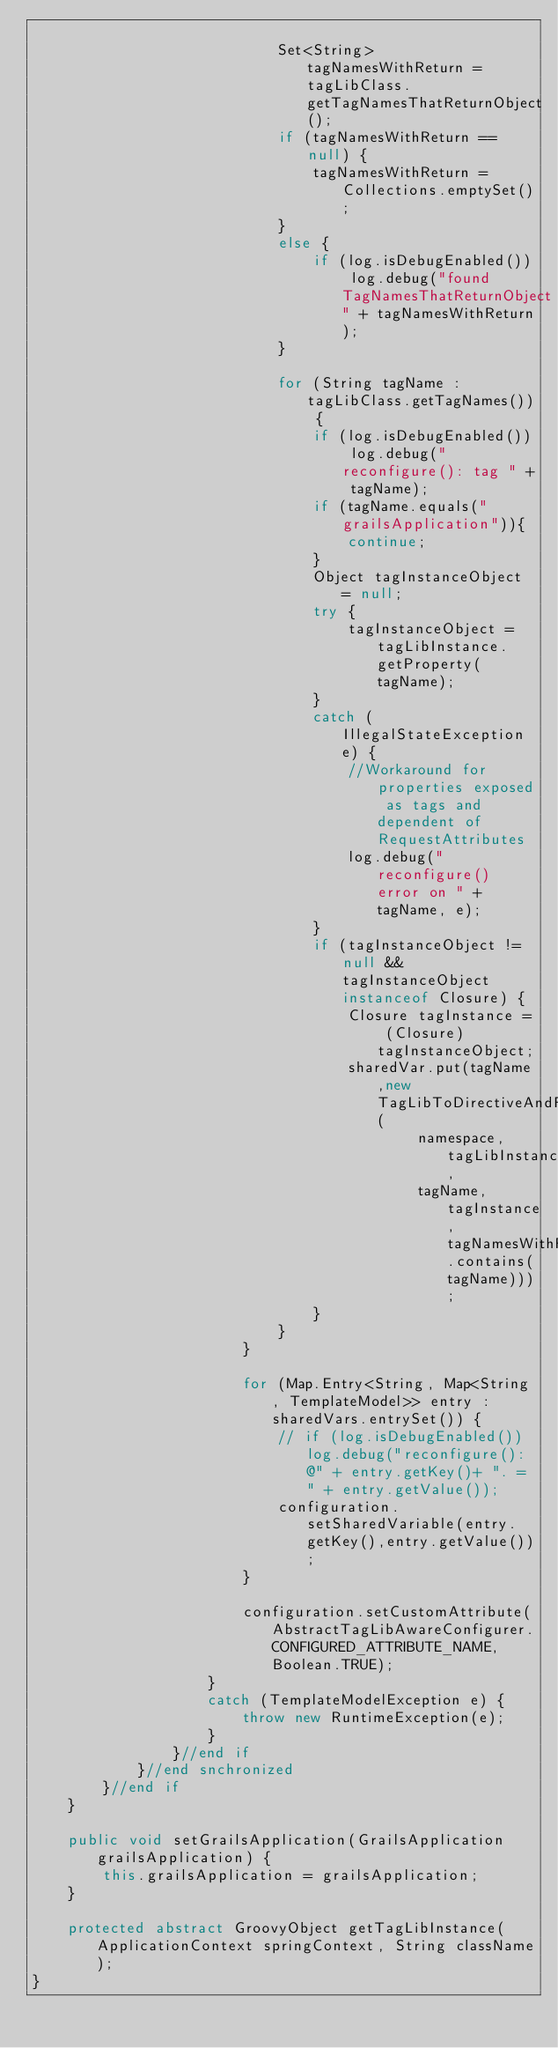<code> <loc_0><loc_0><loc_500><loc_500><_Java_>
                            Set<String> tagNamesWithReturn = tagLibClass.getTagNamesThatReturnObject();
                            if (tagNamesWithReturn == null) {
                                tagNamesWithReturn = Collections.emptySet();
                            }
                            else {
                                if (log.isDebugEnabled()) log.debug("found TagNamesThatReturnObject" + tagNamesWithReturn);
                            }

                            for (String tagName : tagLibClass.getTagNames()) {
                                if (log.isDebugEnabled()) log.debug("reconfigure(): tag " + tagName);
                                if (tagName.equals("grailsApplication")){
                                    continue;
                                }
                                Object tagInstanceObject = null;
                                try {
                                    tagInstanceObject = tagLibInstance.getProperty(tagName);
                                }
                                catch (IllegalStateException e) {
                                    //Workaround for properties exposed as tags and dependent of RequestAttributes
                                    log.debug("reconfigure() error on " + tagName, e);
                                }
                                if (tagInstanceObject != null && tagInstanceObject instanceof Closure) {
                                    Closure tagInstance = (Closure) tagInstanceObject;
                                    sharedVar.put(tagName,new TagLibToDirectiveAndFunction(
                                            namespace, tagLibInstance,
                                            tagName, tagInstance, tagNamesWithReturn.contains(tagName)));
                                }
                            }
                        }

                        for (Map.Entry<String, Map<String, TemplateModel>> entry : sharedVars.entrySet()) {
                            // if (log.isDebugEnabled()) log.debug("reconfigure(): @" + entry.getKey()+ ". = " + entry.getValue());
                            configuration.setSharedVariable(entry.getKey(),entry.getValue());
                        }

                        configuration.setCustomAttribute(AbstractTagLibAwareConfigurer.CONFIGURED_ATTRIBUTE_NAME,Boolean.TRUE);
                    }
                    catch (TemplateModelException e) {
                        throw new RuntimeException(e);
                    }
                }//end if
            }//end snchronized
        }//end if
    }

    public void setGrailsApplication(GrailsApplication grailsApplication) {
        this.grailsApplication = grailsApplication;
    }

    protected abstract GroovyObject getTagLibInstance(ApplicationContext springContext, String className);
}
</code> 